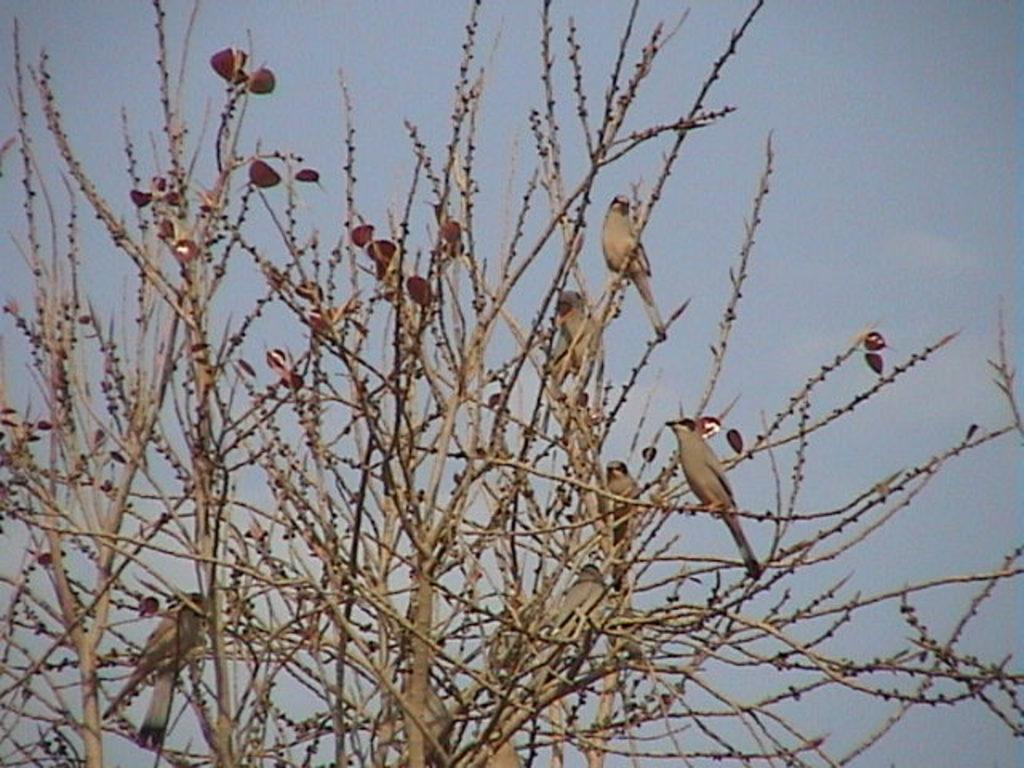What animals can be seen in the image? There are birds on a tree in the image. What is visible in the background of the image? There is a sky visible in the background of the image. How does the fog affect the visibility of the birds in the image? There is no fog present in the image, so it does not affect the visibility of the birds. 